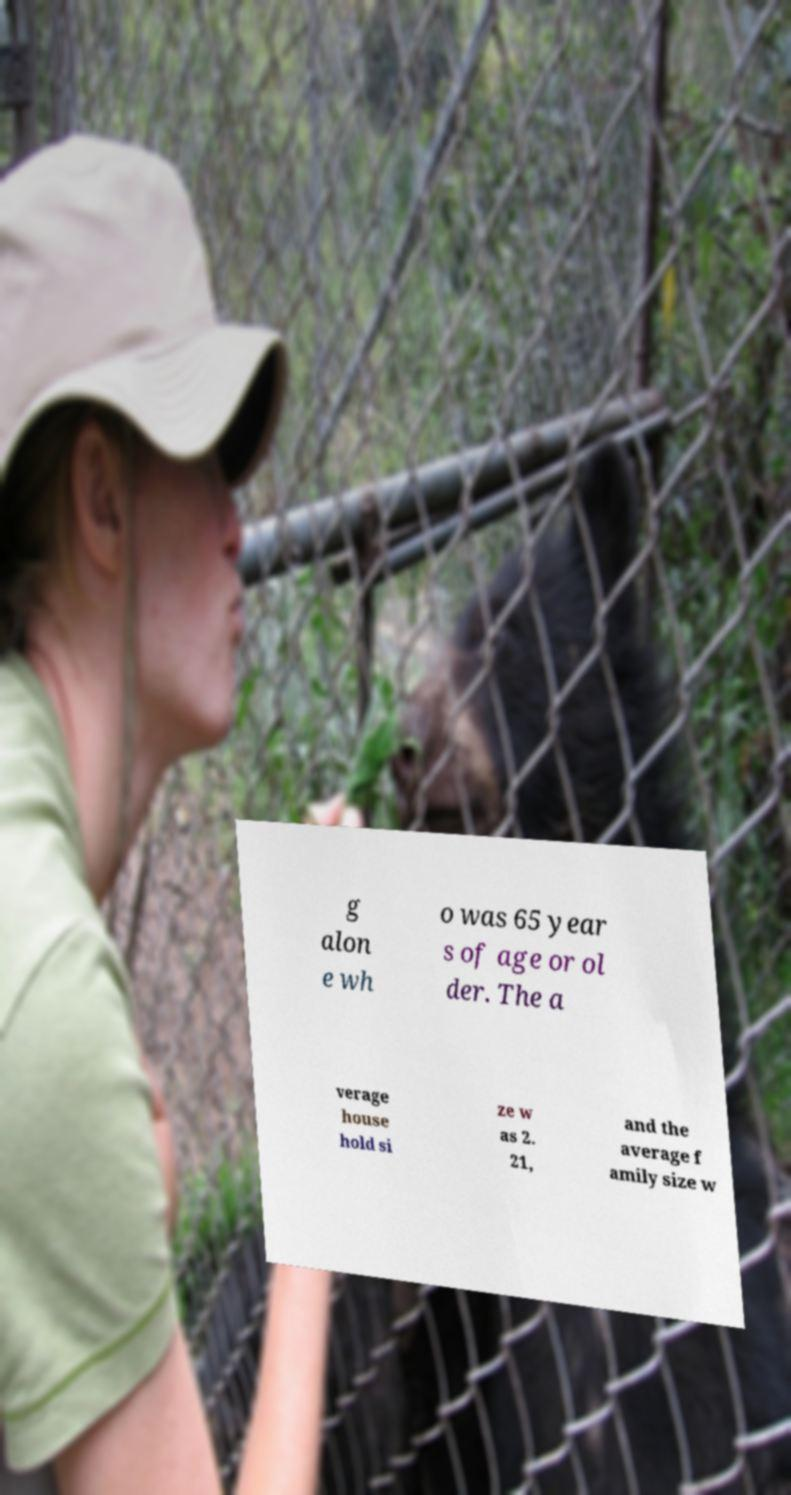For documentation purposes, I need the text within this image transcribed. Could you provide that? g alon e wh o was 65 year s of age or ol der. The a verage house hold si ze w as 2. 21, and the average f amily size w 